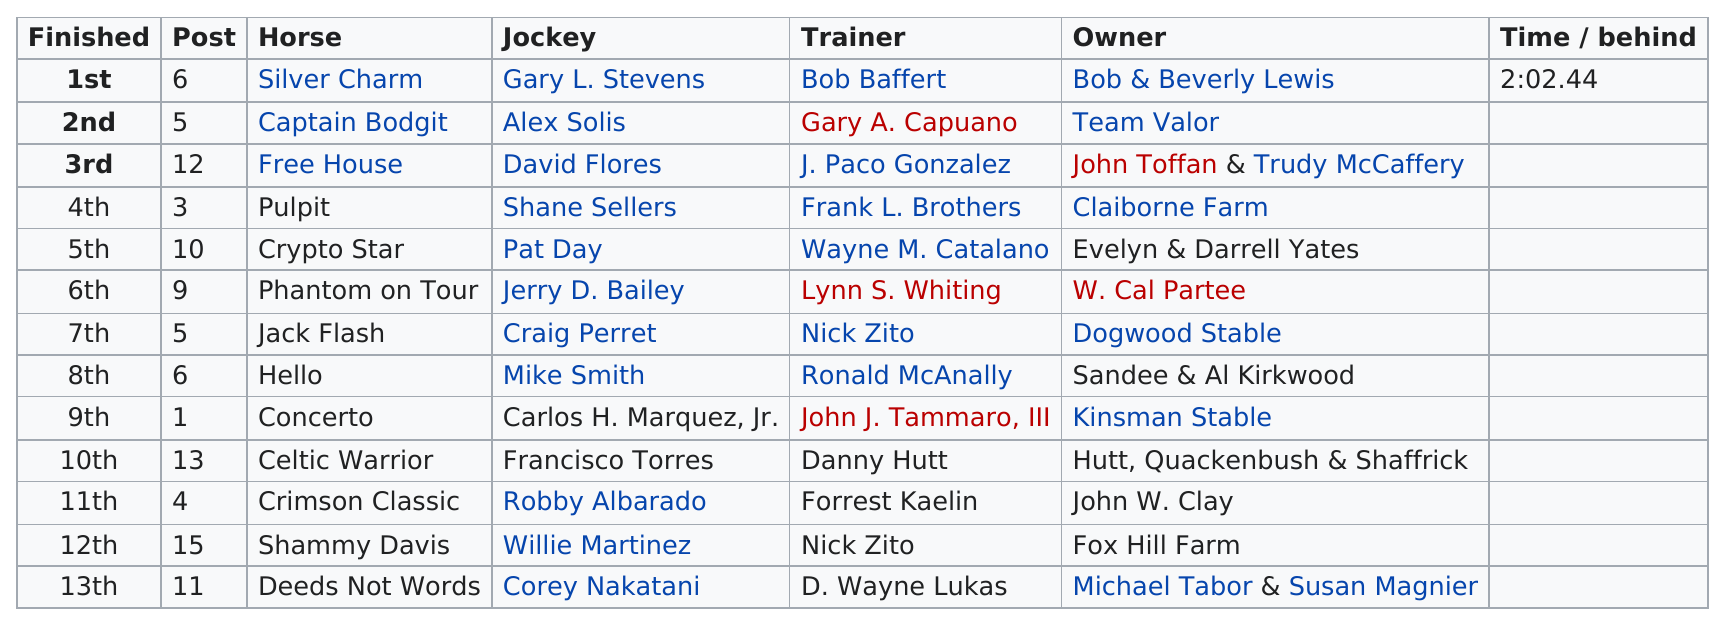Specify some key components in this picture. The top horse is trained by Bob Baffert. The horse that placed fifth is Crypto Star, and the question asks which one of these two options is correct, Crypto Star or Celtic Warrior? I declare that the horse named Deeds Not Words is a horse with three words in its name, other than Phantom on Tour. The trainer of the horse that won the 1997 Kentucky Derby was Bob Baffert. Name a horse that did not place in the top ten of the 1997 Kentucky Derby: Crimson Classic. 